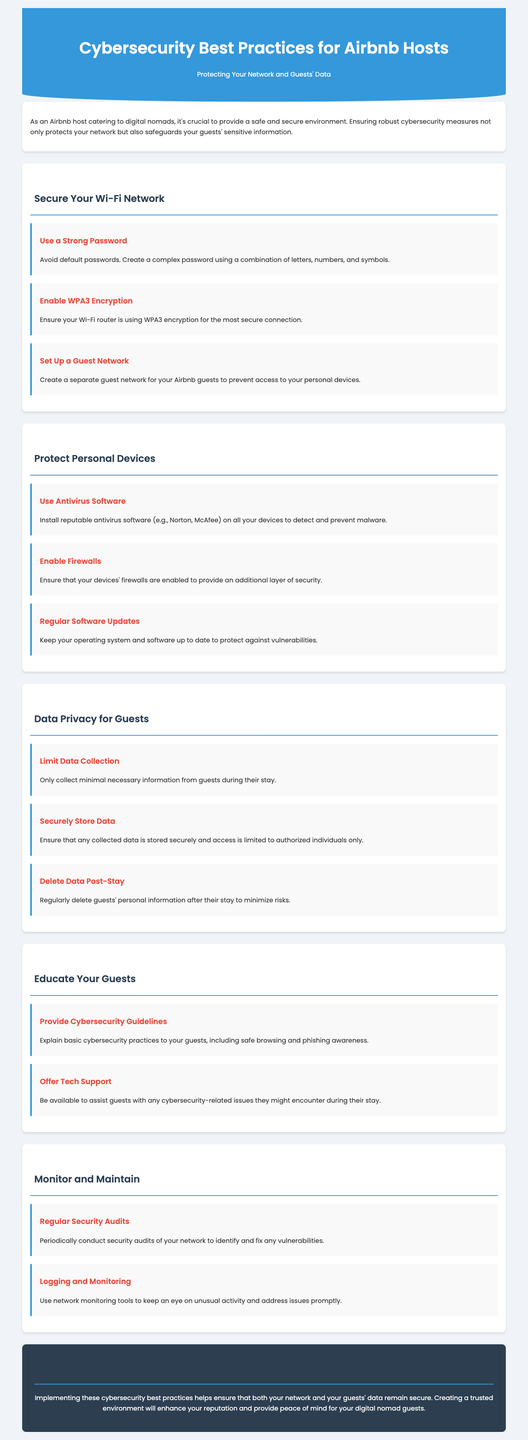What is a recommended Wi-Fi encryption standard? The document suggests using WPA3 encryption for a secure connection.
Answer: WPA3 What type of software should hosts install on devices? The infographic mentions installing reputable antivirus software to detect and prevent malware.
Answer: Antivirus software What should hosts do with guests' personal information after their stay? It is advised to regularly delete guests' personal information to minimize risks.
Answer: Delete data What is a key feature of the guest network? The document states that it separates guest access from personal devices for enhanced security.
Answer: Separate access How often should security audits be conducted? The document suggests conducting security audits periodically to identify vulnerabilities.
Answer: Periodically 